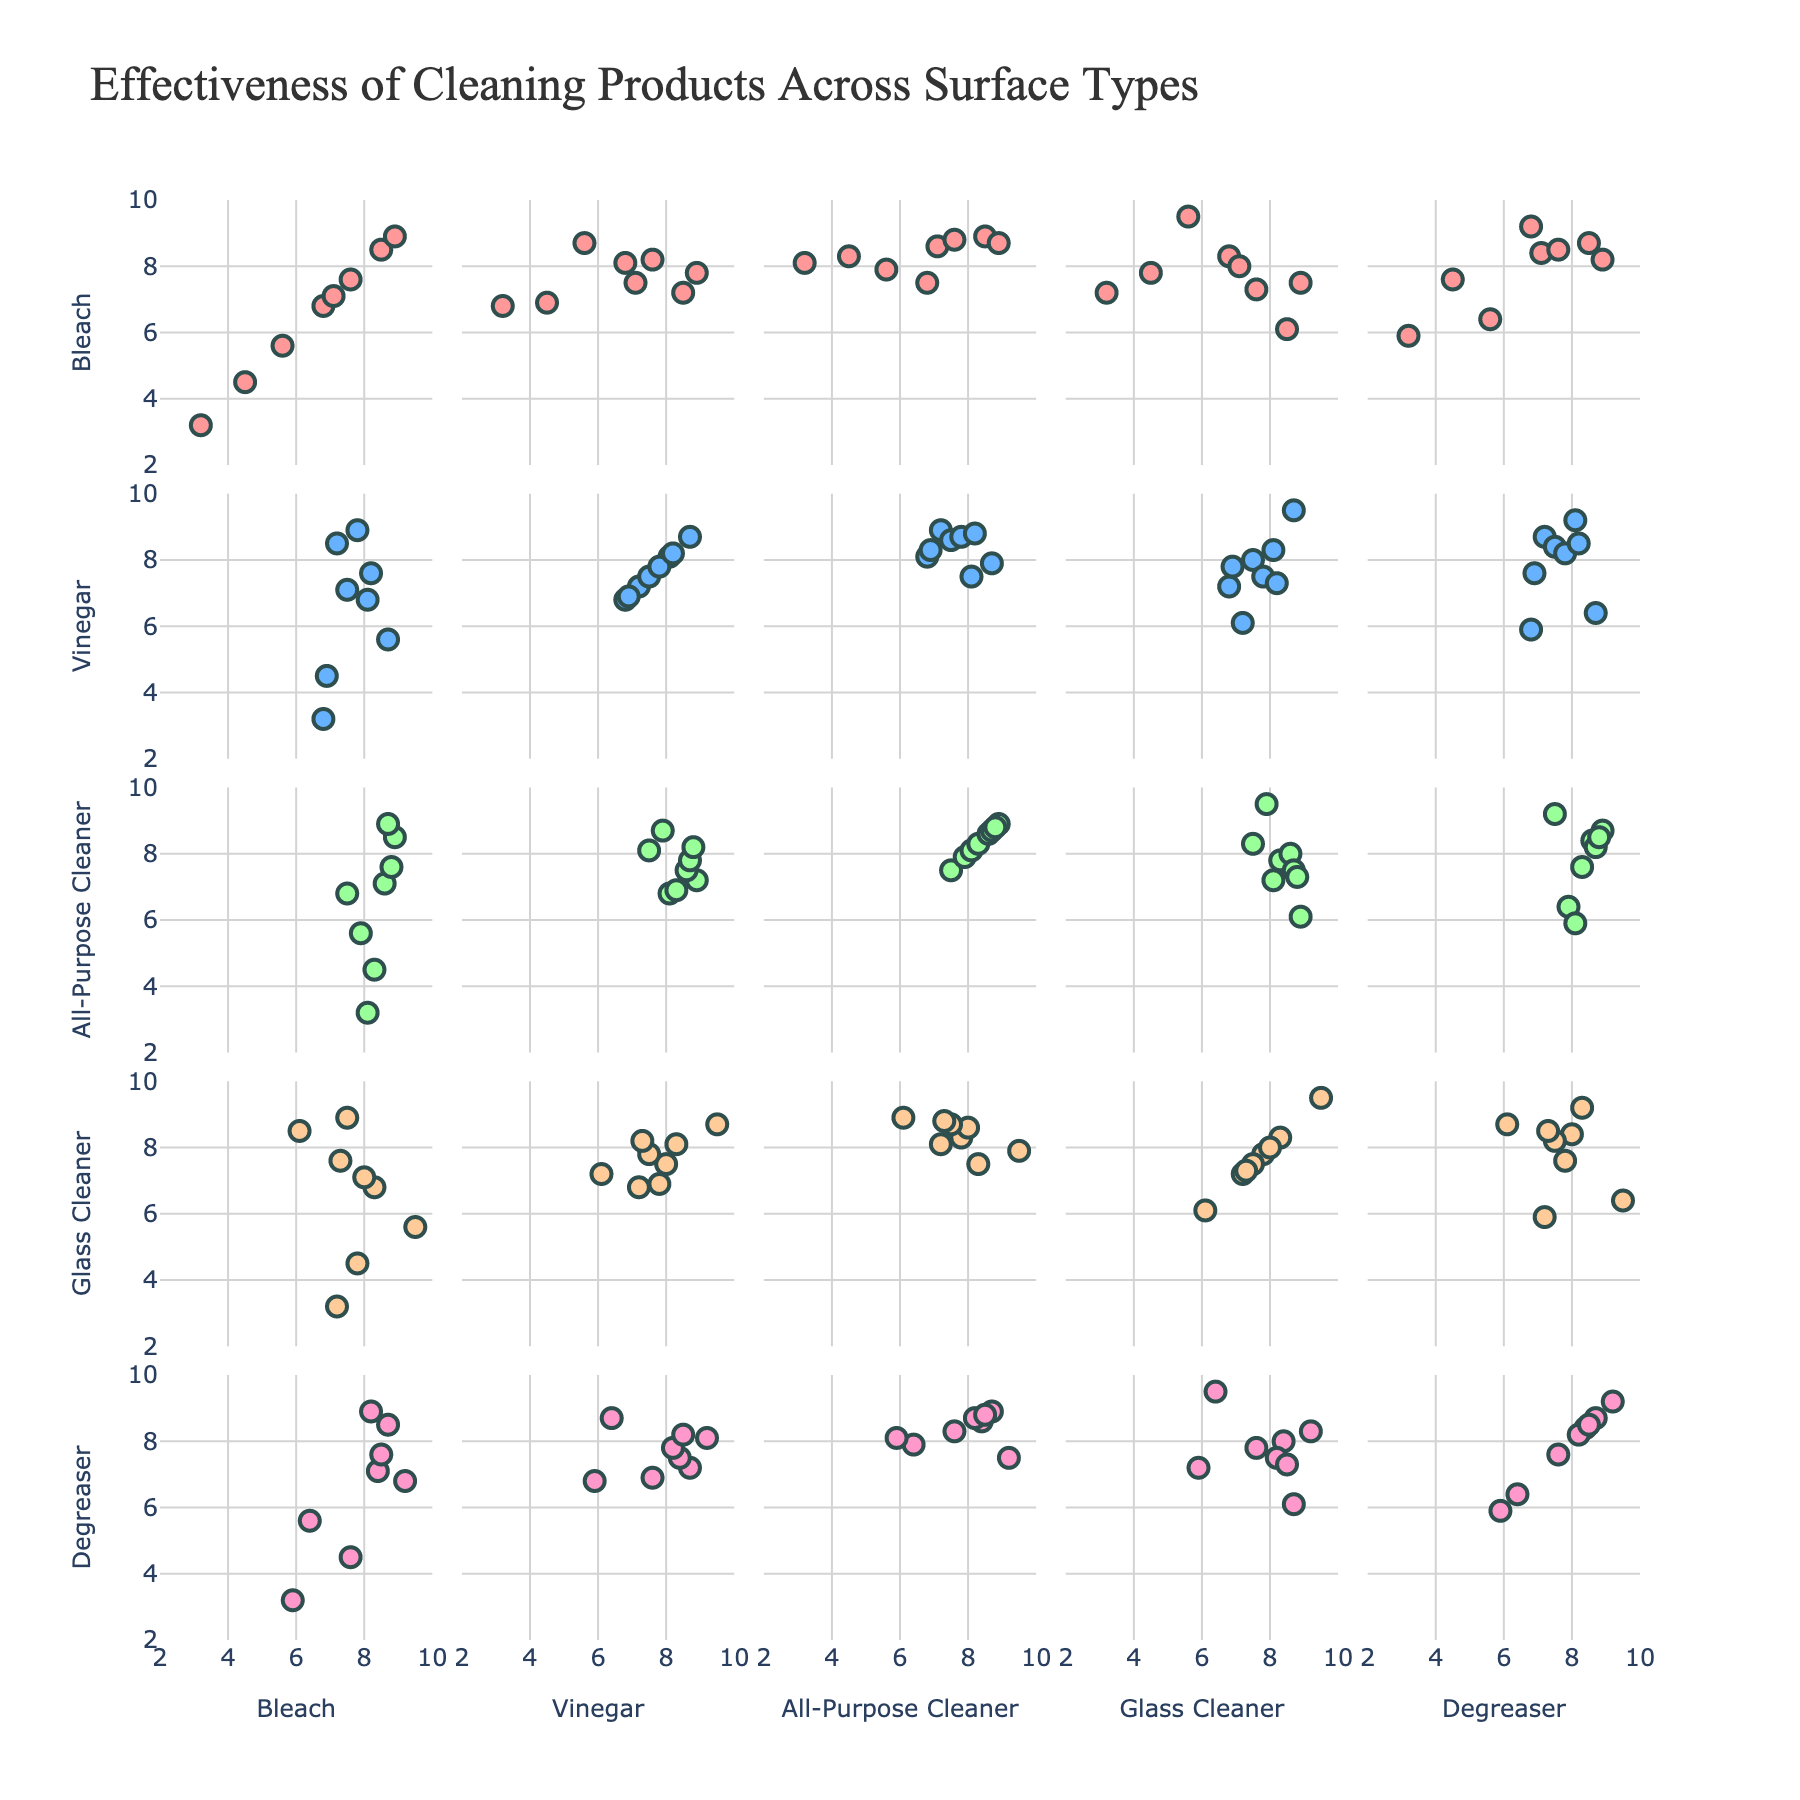What's the title of the figure? The title is located at the top of the figure, and it reads "Effectiveness of Cleaning Products Across Surface Types".
Answer: Effectiveness of Cleaning Products Across Surface Types How many data points are plotted for each scatterplot? Each scatterplot corresponds to a combination of two cleaning products, and there are 8 surface types mentioned in the dataset. Thus, each scatterplot has 8 data points.
Answer: 8 Which surface had the highest effectiveness when cleaned with Bleach? By looking at the label values for data points in the Bleach column where the y-axis is Bleach, Tile shows the highest effectiveness with a value of 8.9.
Answer: Tile Which cleaning product was the most effective on Wood surfaces? On examining the scatterplots where Wood is labeled, the highest y-axis value for Wood is in the All-Purpose Cleaner’s scatterplot with a value of 8.1.
Answer: All-Purpose Cleaner Is there a cleaning product with consistently high effectiveness across different surfaces? By examining each scatterplot, Degreaser consistently shows high effectiveness as all its effectiveness values are above 5 and most are quite high. This can be especially seen in scatterplots where the y-axis is Degreaser.
Answer: Degreaser Compare the effectiveness of Vinegar versus Glass Cleaner on Granite? Looking at the scatterplots where the x-axis is Vinegar and the y-axis is Glass Cleaner, Granite has effectiveness values of 6.9 for Vinegar and 7.8 for Glass Cleaner, showing that Glass Cleaner is more effective on Granite than Vinegar.
Answer: Glass Cleaner Which cleaning product shows the widest range of effectiveness across different surfaces? By observing the scatterplots, Bleach has values ranging from 3.2 to 8.9 across all surfaces, indicating the widest range of effectiveness among all the products.
Answer: Bleach Which surface type had the lowest effectiveness with Bleach? By looking at the Bleach column in the scatterplot matrix, Wood shows the lowest effectiveness with a value of 3.2.
Answer: Wood Compare the average effectiveness of All-Purpose Cleaner on Tile and Ceramic surfaces. The effectiveness values can be seen directly in the scatterplots: 8.9 for Tile and 8.7 for Ceramic. The average is calculated as (8.9 + 8.7) / 2 = 8.8.
Answer: 8.8 Do any two cleaning products have similar effectiveness on all surfaces? By comparing the scatterplots and looking for closely aligned dots along the diagonal line in each plot, All-Purpose Cleaner and Glass Cleaner appear similar as most points align nicely along the diagonal in their respective scatterplots (indicating similar effectiveness over all surfaces).
Answer: Yes, All-Purpose Cleaner and Glass Cleaner 